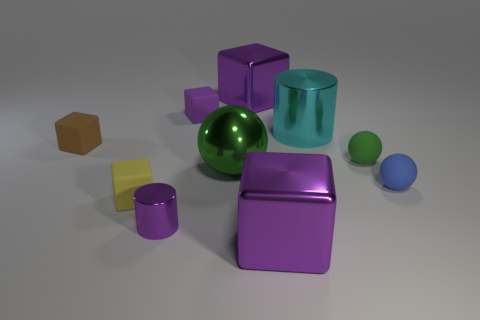Subtract all big blocks. How many blocks are left? 3 Subtract all cyan blocks. How many green balls are left? 2 Subtract all green balls. How many balls are left? 1 Subtract all balls. How many objects are left? 7 Add 9 yellow metallic blocks. How many yellow metallic blocks exist? 9 Subtract 1 cyan cylinders. How many objects are left? 9 Subtract all yellow cubes. Subtract all purple spheres. How many cubes are left? 4 Subtract all tiny red cylinders. Subtract all purple metallic cubes. How many objects are left? 8 Add 1 large metallic cylinders. How many large metallic cylinders are left? 2 